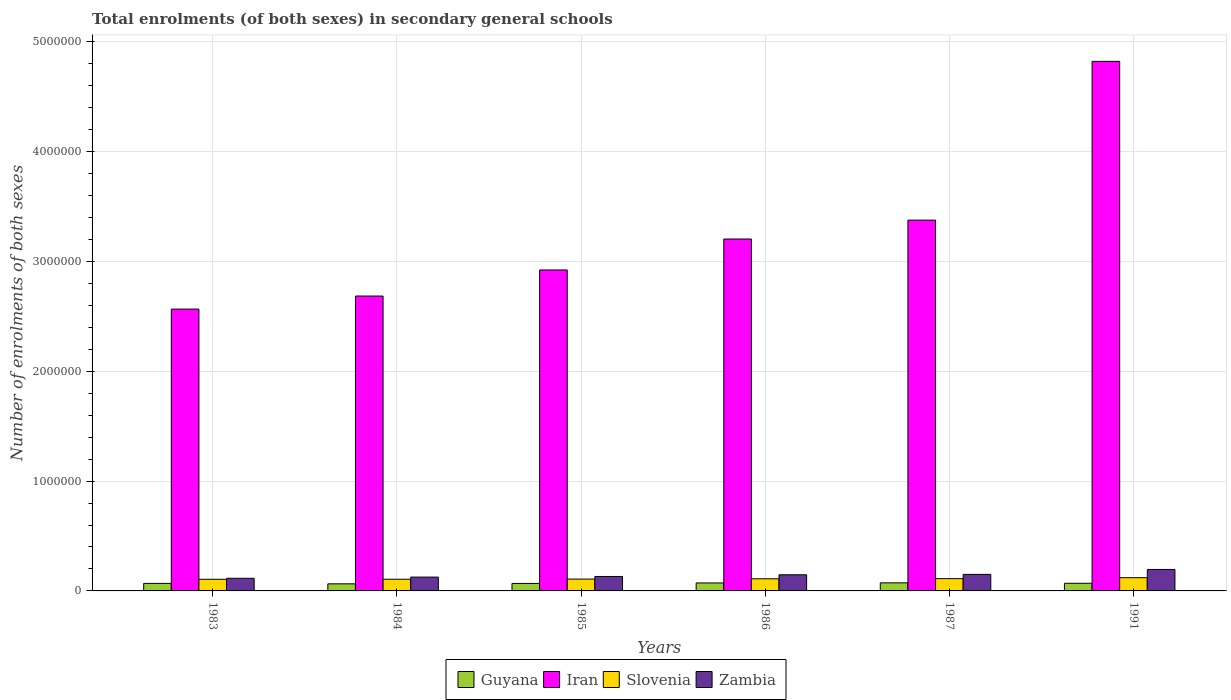Are the number of bars per tick equal to the number of legend labels?
Ensure brevity in your answer.  Yes. Are the number of bars on each tick of the X-axis equal?
Give a very brief answer. Yes. How many bars are there on the 3rd tick from the left?
Ensure brevity in your answer.  4. In how many cases, is the number of bars for a given year not equal to the number of legend labels?
Your response must be concise. 0. What is the number of enrolments in secondary schools in Zambia in 1987?
Offer a terse response. 1.51e+05. Across all years, what is the maximum number of enrolments in secondary schools in Slovenia?
Give a very brief answer. 1.20e+05. Across all years, what is the minimum number of enrolments in secondary schools in Iran?
Keep it short and to the point. 2.57e+06. In which year was the number of enrolments in secondary schools in Zambia minimum?
Offer a very short reply. 1983. What is the total number of enrolments in secondary schools in Guyana in the graph?
Provide a succinct answer. 4.17e+05. What is the difference between the number of enrolments in secondary schools in Slovenia in 1985 and that in 1991?
Your answer should be compact. -1.27e+04. What is the difference between the number of enrolments in secondary schools in Slovenia in 1986 and the number of enrolments in secondary schools in Iran in 1987?
Provide a short and direct response. -3.27e+06. What is the average number of enrolments in secondary schools in Iran per year?
Provide a short and direct response. 3.26e+06. In the year 1983, what is the difference between the number of enrolments in secondary schools in Iran and number of enrolments in secondary schools in Slovenia?
Offer a terse response. 2.46e+06. In how many years, is the number of enrolments in secondary schools in Zambia greater than 3600000?
Provide a short and direct response. 0. What is the ratio of the number of enrolments in secondary schools in Guyana in 1983 to that in 1985?
Your answer should be very brief. 1. Is the number of enrolments in secondary schools in Guyana in 1984 less than that in 1991?
Offer a very short reply. Yes. What is the difference between the highest and the second highest number of enrolments in secondary schools in Zambia?
Give a very brief answer. 4.48e+04. What is the difference between the highest and the lowest number of enrolments in secondary schools in Slovenia?
Your answer should be very brief. 1.45e+04. Is it the case that in every year, the sum of the number of enrolments in secondary schools in Iran and number of enrolments in secondary schools in Slovenia is greater than the sum of number of enrolments in secondary schools in Guyana and number of enrolments in secondary schools in Zambia?
Give a very brief answer. Yes. What does the 1st bar from the left in 1991 represents?
Offer a terse response. Guyana. What does the 2nd bar from the right in 1985 represents?
Offer a very short reply. Slovenia. Is it the case that in every year, the sum of the number of enrolments in secondary schools in Zambia and number of enrolments in secondary schools in Guyana is greater than the number of enrolments in secondary schools in Iran?
Your answer should be very brief. No. How many bars are there?
Make the answer very short. 24. Are all the bars in the graph horizontal?
Offer a terse response. No. How many years are there in the graph?
Ensure brevity in your answer.  6. Are the values on the major ticks of Y-axis written in scientific E-notation?
Your response must be concise. No. How many legend labels are there?
Keep it short and to the point. 4. What is the title of the graph?
Keep it short and to the point. Total enrolments (of both sexes) in secondary general schools. What is the label or title of the X-axis?
Offer a terse response. Years. What is the label or title of the Y-axis?
Make the answer very short. Number of enrolments of both sexes. What is the Number of enrolments of both sexes in Guyana in 1983?
Provide a succinct answer. 6.86e+04. What is the Number of enrolments of both sexes of Iran in 1983?
Your answer should be very brief. 2.57e+06. What is the Number of enrolments of both sexes of Slovenia in 1983?
Offer a very short reply. 1.06e+05. What is the Number of enrolments of both sexes of Zambia in 1983?
Offer a very short reply. 1.15e+05. What is the Number of enrolments of both sexes in Guyana in 1984?
Provide a succinct answer. 6.45e+04. What is the Number of enrolments of both sexes in Iran in 1984?
Offer a terse response. 2.69e+06. What is the Number of enrolments of both sexes in Slovenia in 1984?
Offer a very short reply. 1.06e+05. What is the Number of enrolments of both sexes of Zambia in 1984?
Keep it short and to the point. 1.26e+05. What is the Number of enrolments of both sexes in Guyana in 1985?
Make the answer very short. 6.82e+04. What is the Number of enrolments of both sexes in Iran in 1985?
Give a very brief answer. 2.92e+06. What is the Number of enrolments of both sexes in Slovenia in 1985?
Make the answer very short. 1.08e+05. What is the Number of enrolments of both sexes in Zambia in 1985?
Your answer should be very brief. 1.32e+05. What is the Number of enrolments of both sexes in Guyana in 1986?
Offer a very short reply. 7.27e+04. What is the Number of enrolments of both sexes of Iran in 1986?
Your answer should be very brief. 3.20e+06. What is the Number of enrolments of both sexes of Slovenia in 1986?
Your answer should be compact. 1.10e+05. What is the Number of enrolments of both sexes in Zambia in 1986?
Offer a terse response. 1.47e+05. What is the Number of enrolments of both sexes in Guyana in 1987?
Your answer should be very brief. 7.34e+04. What is the Number of enrolments of both sexes in Iran in 1987?
Keep it short and to the point. 3.38e+06. What is the Number of enrolments of both sexes of Slovenia in 1987?
Offer a very short reply. 1.12e+05. What is the Number of enrolments of both sexes in Zambia in 1987?
Your answer should be very brief. 1.51e+05. What is the Number of enrolments of both sexes in Guyana in 1991?
Keep it short and to the point. 6.97e+04. What is the Number of enrolments of both sexes of Iran in 1991?
Offer a very short reply. 4.82e+06. What is the Number of enrolments of both sexes in Slovenia in 1991?
Your response must be concise. 1.20e+05. What is the Number of enrolments of both sexes in Zambia in 1991?
Keep it short and to the point. 1.95e+05. Across all years, what is the maximum Number of enrolments of both sexes in Guyana?
Provide a short and direct response. 7.34e+04. Across all years, what is the maximum Number of enrolments of both sexes in Iran?
Make the answer very short. 4.82e+06. Across all years, what is the maximum Number of enrolments of both sexes in Slovenia?
Offer a very short reply. 1.20e+05. Across all years, what is the maximum Number of enrolments of both sexes in Zambia?
Your answer should be compact. 1.95e+05. Across all years, what is the minimum Number of enrolments of both sexes of Guyana?
Provide a short and direct response. 6.45e+04. Across all years, what is the minimum Number of enrolments of both sexes of Iran?
Provide a succinct answer. 2.57e+06. Across all years, what is the minimum Number of enrolments of both sexes in Slovenia?
Provide a succinct answer. 1.06e+05. Across all years, what is the minimum Number of enrolments of both sexes of Zambia?
Provide a short and direct response. 1.15e+05. What is the total Number of enrolments of both sexes of Guyana in the graph?
Your answer should be compact. 4.17e+05. What is the total Number of enrolments of both sexes of Iran in the graph?
Ensure brevity in your answer.  1.96e+07. What is the total Number of enrolments of both sexes of Slovenia in the graph?
Give a very brief answer. 6.63e+05. What is the total Number of enrolments of both sexes in Zambia in the graph?
Provide a short and direct response. 8.65e+05. What is the difference between the Number of enrolments of both sexes in Guyana in 1983 and that in 1984?
Offer a terse response. 4042. What is the difference between the Number of enrolments of both sexes of Iran in 1983 and that in 1984?
Give a very brief answer. -1.19e+05. What is the difference between the Number of enrolments of both sexes of Slovenia in 1983 and that in 1984?
Ensure brevity in your answer.  -549. What is the difference between the Number of enrolments of both sexes in Zambia in 1983 and that in 1984?
Keep it short and to the point. -1.07e+04. What is the difference between the Number of enrolments of both sexes of Guyana in 1983 and that in 1985?
Your response must be concise. 338. What is the difference between the Number of enrolments of both sexes of Iran in 1983 and that in 1985?
Your response must be concise. -3.56e+05. What is the difference between the Number of enrolments of both sexes of Slovenia in 1983 and that in 1985?
Make the answer very short. -1803. What is the difference between the Number of enrolments of both sexes in Zambia in 1983 and that in 1985?
Ensure brevity in your answer.  -1.64e+04. What is the difference between the Number of enrolments of both sexes of Guyana in 1983 and that in 1986?
Your response must be concise. -4119. What is the difference between the Number of enrolments of both sexes of Iran in 1983 and that in 1986?
Provide a succinct answer. -6.38e+05. What is the difference between the Number of enrolments of both sexes in Slovenia in 1983 and that in 1986?
Provide a succinct answer. -4548. What is the difference between the Number of enrolments of both sexes of Zambia in 1983 and that in 1986?
Keep it short and to the point. -3.19e+04. What is the difference between the Number of enrolments of both sexes in Guyana in 1983 and that in 1987?
Offer a terse response. -4858. What is the difference between the Number of enrolments of both sexes of Iran in 1983 and that in 1987?
Your answer should be very brief. -8.10e+05. What is the difference between the Number of enrolments of both sexes of Slovenia in 1983 and that in 1987?
Your answer should be compact. -5908. What is the difference between the Number of enrolments of both sexes in Zambia in 1983 and that in 1987?
Give a very brief answer. -3.56e+04. What is the difference between the Number of enrolments of both sexes in Guyana in 1983 and that in 1991?
Keep it short and to the point. -1136. What is the difference between the Number of enrolments of both sexes in Iran in 1983 and that in 1991?
Offer a very short reply. -2.26e+06. What is the difference between the Number of enrolments of both sexes in Slovenia in 1983 and that in 1991?
Ensure brevity in your answer.  -1.45e+04. What is the difference between the Number of enrolments of both sexes in Zambia in 1983 and that in 1991?
Ensure brevity in your answer.  -8.03e+04. What is the difference between the Number of enrolments of both sexes in Guyana in 1984 and that in 1985?
Keep it short and to the point. -3704. What is the difference between the Number of enrolments of both sexes in Iran in 1984 and that in 1985?
Your answer should be compact. -2.38e+05. What is the difference between the Number of enrolments of both sexes of Slovenia in 1984 and that in 1985?
Your answer should be compact. -1254. What is the difference between the Number of enrolments of both sexes in Zambia in 1984 and that in 1985?
Keep it short and to the point. -5691. What is the difference between the Number of enrolments of both sexes in Guyana in 1984 and that in 1986?
Your response must be concise. -8161. What is the difference between the Number of enrolments of both sexes of Iran in 1984 and that in 1986?
Provide a succinct answer. -5.19e+05. What is the difference between the Number of enrolments of both sexes in Slovenia in 1984 and that in 1986?
Ensure brevity in your answer.  -3999. What is the difference between the Number of enrolments of both sexes of Zambia in 1984 and that in 1986?
Make the answer very short. -2.12e+04. What is the difference between the Number of enrolments of both sexes in Guyana in 1984 and that in 1987?
Give a very brief answer. -8900. What is the difference between the Number of enrolments of both sexes of Iran in 1984 and that in 1987?
Make the answer very short. -6.91e+05. What is the difference between the Number of enrolments of both sexes in Slovenia in 1984 and that in 1987?
Ensure brevity in your answer.  -5359. What is the difference between the Number of enrolments of both sexes in Zambia in 1984 and that in 1987?
Keep it short and to the point. -2.48e+04. What is the difference between the Number of enrolments of both sexes in Guyana in 1984 and that in 1991?
Provide a short and direct response. -5178. What is the difference between the Number of enrolments of both sexes of Iran in 1984 and that in 1991?
Give a very brief answer. -2.14e+06. What is the difference between the Number of enrolments of both sexes of Slovenia in 1984 and that in 1991?
Your answer should be compact. -1.40e+04. What is the difference between the Number of enrolments of both sexes of Zambia in 1984 and that in 1991?
Give a very brief answer. -6.96e+04. What is the difference between the Number of enrolments of both sexes in Guyana in 1985 and that in 1986?
Your response must be concise. -4457. What is the difference between the Number of enrolments of both sexes of Iran in 1985 and that in 1986?
Keep it short and to the point. -2.82e+05. What is the difference between the Number of enrolments of both sexes of Slovenia in 1985 and that in 1986?
Ensure brevity in your answer.  -2745. What is the difference between the Number of enrolments of both sexes in Zambia in 1985 and that in 1986?
Offer a very short reply. -1.55e+04. What is the difference between the Number of enrolments of both sexes of Guyana in 1985 and that in 1987?
Offer a very short reply. -5196. What is the difference between the Number of enrolments of both sexes of Iran in 1985 and that in 1987?
Give a very brief answer. -4.54e+05. What is the difference between the Number of enrolments of both sexes in Slovenia in 1985 and that in 1987?
Your answer should be compact. -4105. What is the difference between the Number of enrolments of both sexes in Zambia in 1985 and that in 1987?
Make the answer very short. -1.91e+04. What is the difference between the Number of enrolments of both sexes in Guyana in 1985 and that in 1991?
Offer a very short reply. -1474. What is the difference between the Number of enrolments of both sexes of Iran in 1985 and that in 1991?
Your answer should be compact. -1.90e+06. What is the difference between the Number of enrolments of both sexes in Slovenia in 1985 and that in 1991?
Your answer should be very brief. -1.27e+04. What is the difference between the Number of enrolments of both sexes of Zambia in 1985 and that in 1991?
Offer a terse response. -6.39e+04. What is the difference between the Number of enrolments of both sexes of Guyana in 1986 and that in 1987?
Your answer should be compact. -739. What is the difference between the Number of enrolments of both sexes in Iran in 1986 and that in 1987?
Give a very brief answer. -1.72e+05. What is the difference between the Number of enrolments of both sexes in Slovenia in 1986 and that in 1987?
Make the answer very short. -1360. What is the difference between the Number of enrolments of both sexes of Zambia in 1986 and that in 1987?
Offer a terse response. -3660. What is the difference between the Number of enrolments of both sexes in Guyana in 1986 and that in 1991?
Give a very brief answer. 2983. What is the difference between the Number of enrolments of both sexes in Iran in 1986 and that in 1991?
Make the answer very short. -1.62e+06. What is the difference between the Number of enrolments of both sexes of Slovenia in 1986 and that in 1991?
Your answer should be compact. -9958. What is the difference between the Number of enrolments of both sexes in Zambia in 1986 and that in 1991?
Make the answer very short. -4.84e+04. What is the difference between the Number of enrolments of both sexes of Guyana in 1987 and that in 1991?
Offer a very short reply. 3722. What is the difference between the Number of enrolments of both sexes of Iran in 1987 and that in 1991?
Keep it short and to the point. -1.45e+06. What is the difference between the Number of enrolments of both sexes of Slovenia in 1987 and that in 1991?
Provide a succinct answer. -8598. What is the difference between the Number of enrolments of both sexes in Zambia in 1987 and that in 1991?
Your response must be concise. -4.48e+04. What is the difference between the Number of enrolments of both sexes in Guyana in 1983 and the Number of enrolments of both sexes in Iran in 1984?
Offer a very short reply. -2.62e+06. What is the difference between the Number of enrolments of both sexes in Guyana in 1983 and the Number of enrolments of both sexes in Slovenia in 1984?
Offer a very short reply. -3.79e+04. What is the difference between the Number of enrolments of both sexes in Guyana in 1983 and the Number of enrolments of both sexes in Zambia in 1984?
Your answer should be compact. -5.73e+04. What is the difference between the Number of enrolments of both sexes in Iran in 1983 and the Number of enrolments of both sexes in Slovenia in 1984?
Your answer should be compact. 2.46e+06. What is the difference between the Number of enrolments of both sexes of Iran in 1983 and the Number of enrolments of both sexes of Zambia in 1984?
Offer a very short reply. 2.44e+06. What is the difference between the Number of enrolments of both sexes of Slovenia in 1983 and the Number of enrolments of both sexes of Zambia in 1984?
Provide a succinct answer. -1.99e+04. What is the difference between the Number of enrolments of both sexes in Guyana in 1983 and the Number of enrolments of both sexes in Iran in 1985?
Your answer should be compact. -2.85e+06. What is the difference between the Number of enrolments of both sexes of Guyana in 1983 and the Number of enrolments of both sexes of Slovenia in 1985?
Provide a short and direct response. -3.91e+04. What is the difference between the Number of enrolments of both sexes in Guyana in 1983 and the Number of enrolments of both sexes in Zambia in 1985?
Keep it short and to the point. -6.29e+04. What is the difference between the Number of enrolments of both sexes in Iran in 1983 and the Number of enrolments of both sexes in Slovenia in 1985?
Offer a terse response. 2.46e+06. What is the difference between the Number of enrolments of both sexes of Iran in 1983 and the Number of enrolments of both sexes of Zambia in 1985?
Offer a very short reply. 2.43e+06. What is the difference between the Number of enrolments of both sexes in Slovenia in 1983 and the Number of enrolments of both sexes in Zambia in 1985?
Your answer should be compact. -2.56e+04. What is the difference between the Number of enrolments of both sexes of Guyana in 1983 and the Number of enrolments of both sexes of Iran in 1986?
Give a very brief answer. -3.14e+06. What is the difference between the Number of enrolments of both sexes of Guyana in 1983 and the Number of enrolments of both sexes of Slovenia in 1986?
Your answer should be very brief. -4.19e+04. What is the difference between the Number of enrolments of both sexes of Guyana in 1983 and the Number of enrolments of both sexes of Zambia in 1986?
Your answer should be very brief. -7.84e+04. What is the difference between the Number of enrolments of both sexes of Iran in 1983 and the Number of enrolments of both sexes of Slovenia in 1986?
Your answer should be compact. 2.46e+06. What is the difference between the Number of enrolments of both sexes in Iran in 1983 and the Number of enrolments of both sexes in Zambia in 1986?
Give a very brief answer. 2.42e+06. What is the difference between the Number of enrolments of both sexes of Slovenia in 1983 and the Number of enrolments of both sexes of Zambia in 1986?
Offer a very short reply. -4.11e+04. What is the difference between the Number of enrolments of both sexes of Guyana in 1983 and the Number of enrolments of both sexes of Iran in 1987?
Provide a succinct answer. -3.31e+06. What is the difference between the Number of enrolments of both sexes in Guyana in 1983 and the Number of enrolments of both sexes in Slovenia in 1987?
Make the answer very short. -4.32e+04. What is the difference between the Number of enrolments of both sexes of Guyana in 1983 and the Number of enrolments of both sexes of Zambia in 1987?
Provide a short and direct response. -8.21e+04. What is the difference between the Number of enrolments of both sexes of Iran in 1983 and the Number of enrolments of both sexes of Slovenia in 1987?
Offer a terse response. 2.45e+06. What is the difference between the Number of enrolments of both sexes in Iran in 1983 and the Number of enrolments of both sexes in Zambia in 1987?
Offer a terse response. 2.42e+06. What is the difference between the Number of enrolments of both sexes in Slovenia in 1983 and the Number of enrolments of both sexes in Zambia in 1987?
Offer a terse response. -4.47e+04. What is the difference between the Number of enrolments of both sexes of Guyana in 1983 and the Number of enrolments of both sexes of Iran in 1991?
Offer a terse response. -4.75e+06. What is the difference between the Number of enrolments of both sexes of Guyana in 1983 and the Number of enrolments of both sexes of Slovenia in 1991?
Provide a succinct answer. -5.18e+04. What is the difference between the Number of enrolments of both sexes of Guyana in 1983 and the Number of enrolments of both sexes of Zambia in 1991?
Make the answer very short. -1.27e+05. What is the difference between the Number of enrolments of both sexes of Iran in 1983 and the Number of enrolments of both sexes of Slovenia in 1991?
Provide a succinct answer. 2.45e+06. What is the difference between the Number of enrolments of both sexes in Iran in 1983 and the Number of enrolments of both sexes in Zambia in 1991?
Your answer should be very brief. 2.37e+06. What is the difference between the Number of enrolments of both sexes in Slovenia in 1983 and the Number of enrolments of both sexes in Zambia in 1991?
Keep it short and to the point. -8.95e+04. What is the difference between the Number of enrolments of both sexes in Guyana in 1984 and the Number of enrolments of both sexes in Iran in 1985?
Your response must be concise. -2.86e+06. What is the difference between the Number of enrolments of both sexes of Guyana in 1984 and the Number of enrolments of both sexes of Slovenia in 1985?
Provide a succinct answer. -4.32e+04. What is the difference between the Number of enrolments of both sexes in Guyana in 1984 and the Number of enrolments of both sexes in Zambia in 1985?
Offer a very short reply. -6.70e+04. What is the difference between the Number of enrolments of both sexes of Iran in 1984 and the Number of enrolments of both sexes of Slovenia in 1985?
Provide a succinct answer. 2.58e+06. What is the difference between the Number of enrolments of both sexes in Iran in 1984 and the Number of enrolments of both sexes in Zambia in 1985?
Offer a terse response. 2.55e+06. What is the difference between the Number of enrolments of both sexes of Slovenia in 1984 and the Number of enrolments of both sexes of Zambia in 1985?
Make the answer very short. -2.51e+04. What is the difference between the Number of enrolments of both sexes in Guyana in 1984 and the Number of enrolments of both sexes in Iran in 1986?
Keep it short and to the point. -3.14e+06. What is the difference between the Number of enrolments of both sexes of Guyana in 1984 and the Number of enrolments of both sexes of Slovenia in 1986?
Your answer should be very brief. -4.59e+04. What is the difference between the Number of enrolments of both sexes in Guyana in 1984 and the Number of enrolments of both sexes in Zambia in 1986?
Make the answer very short. -8.25e+04. What is the difference between the Number of enrolments of both sexes in Iran in 1984 and the Number of enrolments of both sexes in Slovenia in 1986?
Provide a short and direct response. 2.57e+06. What is the difference between the Number of enrolments of both sexes of Iran in 1984 and the Number of enrolments of both sexes of Zambia in 1986?
Your response must be concise. 2.54e+06. What is the difference between the Number of enrolments of both sexes in Slovenia in 1984 and the Number of enrolments of both sexes in Zambia in 1986?
Keep it short and to the point. -4.05e+04. What is the difference between the Number of enrolments of both sexes of Guyana in 1984 and the Number of enrolments of both sexes of Iran in 1987?
Make the answer very short. -3.31e+06. What is the difference between the Number of enrolments of both sexes of Guyana in 1984 and the Number of enrolments of both sexes of Slovenia in 1987?
Offer a very short reply. -4.73e+04. What is the difference between the Number of enrolments of both sexes in Guyana in 1984 and the Number of enrolments of both sexes in Zambia in 1987?
Offer a terse response. -8.61e+04. What is the difference between the Number of enrolments of both sexes in Iran in 1984 and the Number of enrolments of both sexes in Slovenia in 1987?
Provide a short and direct response. 2.57e+06. What is the difference between the Number of enrolments of both sexes of Iran in 1984 and the Number of enrolments of both sexes of Zambia in 1987?
Keep it short and to the point. 2.53e+06. What is the difference between the Number of enrolments of both sexes of Slovenia in 1984 and the Number of enrolments of both sexes of Zambia in 1987?
Your response must be concise. -4.42e+04. What is the difference between the Number of enrolments of both sexes of Guyana in 1984 and the Number of enrolments of both sexes of Iran in 1991?
Offer a very short reply. -4.76e+06. What is the difference between the Number of enrolments of both sexes in Guyana in 1984 and the Number of enrolments of both sexes in Slovenia in 1991?
Keep it short and to the point. -5.59e+04. What is the difference between the Number of enrolments of both sexes of Guyana in 1984 and the Number of enrolments of both sexes of Zambia in 1991?
Your answer should be very brief. -1.31e+05. What is the difference between the Number of enrolments of both sexes of Iran in 1984 and the Number of enrolments of both sexes of Slovenia in 1991?
Make the answer very short. 2.56e+06. What is the difference between the Number of enrolments of both sexes in Iran in 1984 and the Number of enrolments of both sexes in Zambia in 1991?
Your answer should be compact. 2.49e+06. What is the difference between the Number of enrolments of both sexes in Slovenia in 1984 and the Number of enrolments of both sexes in Zambia in 1991?
Your answer should be very brief. -8.90e+04. What is the difference between the Number of enrolments of both sexes of Guyana in 1985 and the Number of enrolments of both sexes of Iran in 1986?
Keep it short and to the point. -3.14e+06. What is the difference between the Number of enrolments of both sexes in Guyana in 1985 and the Number of enrolments of both sexes in Slovenia in 1986?
Offer a terse response. -4.22e+04. What is the difference between the Number of enrolments of both sexes in Guyana in 1985 and the Number of enrolments of both sexes in Zambia in 1986?
Provide a short and direct response. -7.88e+04. What is the difference between the Number of enrolments of both sexes in Iran in 1985 and the Number of enrolments of both sexes in Slovenia in 1986?
Your response must be concise. 2.81e+06. What is the difference between the Number of enrolments of both sexes in Iran in 1985 and the Number of enrolments of both sexes in Zambia in 1986?
Provide a succinct answer. 2.78e+06. What is the difference between the Number of enrolments of both sexes in Slovenia in 1985 and the Number of enrolments of both sexes in Zambia in 1986?
Offer a terse response. -3.93e+04. What is the difference between the Number of enrolments of both sexes of Guyana in 1985 and the Number of enrolments of both sexes of Iran in 1987?
Your answer should be very brief. -3.31e+06. What is the difference between the Number of enrolments of both sexes in Guyana in 1985 and the Number of enrolments of both sexes in Slovenia in 1987?
Give a very brief answer. -4.36e+04. What is the difference between the Number of enrolments of both sexes of Guyana in 1985 and the Number of enrolments of both sexes of Zambia in 1987?
Offer a very short reply. -8.24e+04. What is the difference between the Number of enrolments of both sexes of Iran in 1985 and the Number of enrolments of both sexes of Slovenia in 1987?
Provide a succinct answer. 2.81e+06. What is the difference between the Number of enrolments of both sexes in Iran in 1985 and the Number of enrolments of both sexes in Zambia in 1987?
Provide a succinct answer. 2.77e+06. What is the difference between the Number of enrolments of both sexes of Slovenia in 1985 and the Number of enrolments of both sexes of Zambia in 1987?
Provide a short and direct response. -4.29e+04. What is the difference between the Number of enrolments of both sexes in Guyana in 1985 and the Number of enrolments of both sexes in Iran in 1991?
Provide a succinct answer. -4.75e+06. What is the difference between the Number of enrolments of both sexes of Guyana in 1985 and the Number of enrolments of both sexes of Slovenia in 1991?
Offer a terse response. -5.22e+04. What is the difference between the Number of enrolments of both sexes in Guyana in 1985 and the Number of enrolments of both sexes in Zambia in 1991?
Keep it short and to the point. -1.27e+05. What is the difference between the Number of enrolments of both sexes of Iran in 1985 and the Number of enrolments of both sexes of Slovenia in 1991?
Ensure brevity in your answer.  2.80e+06. What is the difference between the Number of enrolments of both sexes of Iran in 1985 and the Number of enrolments of both sexes of Zambia in 1991?
Your answer should be compact. 2.73e+06. What is the difference between the Number of enrolments of both sexes of Slovenia in 1985 and the Number of enrolments of both sexes of Zambia in 1991?
Offer a very short reply. -8.77e+04. What is the difference between the Number of enrolments of both sexes of Guyana in 1986 and the Number of enrolments of both sexes of Iran in 1987?
Keep it short and to the point. -3.30e+06. What is the difference between the Number of enrolments of both sexes of Guyana in 1986 and the Number of enrolments of both sexes of Slovenia in 1987?
Offer a very short reply. -3.91e+04. What is the difference between the Number of enrolments of both sexes in Guyana in 1986 and the Number of enrolments of both sexes in Zambia in 1987?
Your answer should be compact. -7.80e+04. What is the difference between the Number of enrolments of both sexes of Iran in 1986 and the Number of enrolments of both sexes of Slovenia in 1987?
Provide a succinct answer. 3.09e+06. What is the difference between the Number of enrolments of both sexes of Iran in 1986 and the Number of enrolments of both sexes of Zambia in 1987?
Give a very brief answer. 3.05e+06. What is the difference between the Number of enrolments of both sexes in Slovenia in 1986 and the Number of enrolments of both sexes in Zambia in 1987?
Offer a very short reply. -4.02e+04. What is the difference between the Number of enrolments of both sexes of Guyana in 1986 and the Number of enrolments of both sexes of Iran in 1991?
Provide a short and direct response. -4.75e+06. What is the difference between the Number of enrolments of both sexes in Guyana in 1986 and the Number of enrolments of both sexes in Slovenia in 1991?
Provide a short and direct response. -4.77e+04. What is the difference between the Number of enrolments of both sexes in Guyana in 1986 and the Number of enrolments of both sexes in Zambia in 1991?
Give a very brief answer. -1.23e+05. What is the difference between the Number of enrolments of both sexes in Iran in 1986 and the Number of enrolments of both sexes in Slovenia in 1991?
Give a very brief answer. 3.08e+06. What is the difference between the Number of enrolments of both sexes in Iran in 1986 and the Number of enrolments of both sexes in Zambia in 1991?
Keep it short and to the point. 3.01e+06. What is the difference between the Number of enrolments of both sexes of Slovenia in 1986 and the Number of enrolments of both sexes of Zambia in 1991?
Provide a succinct answer. -8.50e+04. What is the difference between the Number of enrolments of both sexes in Guyana in 1987 and the Number of enrolments of both sexes in Iran in 1991?
Ensure brevity in your answer.  -4.75e+06. What is the difference between the Number of enrolments of both sexes of Guyana in 1987 and the Number of enrolments of both sexes of Slovenia in 1991?
Your answer should be compact. -4.70e+04. What is the difference between the Number of enrolments of both sexes in Guyana in 1987 and the Number of enrolments of both sexes in Zambia in 1991?
Keep it short and to the point. -1.22e+05. What is the difference between the Number of enrolments of both sexes of Iran in 1987 and the Number of enrolments of both sexes of Slovenia in 1991?
Offer a terse response. 3.26e+06. What is the difference between the Number of enrolments of both sexes in Iran in 1987 and the Number of enrolments of both sexes in Zambia in 1991?
Keep it short and to the point. 3.18e+06. What is the difference between the Number of enrolments of both sexes of Slovenia in 1987 and the Number of enrolments of both sexes of Zambia in 1991?
Offer a very short reply. -8.36e+04. What is the average Number of enrolments of both sexes in Guyana per year?
Make the answer very short. 6.95e+04. What is the average Number of enrolments of both sexes of Iran per year?
Make the answer very short. 3.26e+06. What is the average Number of enrolments of both sexes in Slovenia per year?
Make the answer very short. 1.10e+05. What is the average Number of enrolments of both sexes of Zambia per year?
Your response must be concise. 1.44e+05. In the year 1983, what is the difference between the Number of enrolments of both sexes of Guyana and Number of enrolments of both sexes of Iran?
Provide a short and direct response. -2.50e+06. In the year 1983, what is the difference between the Number of enrolments of both sexes in Guyana and Number of enrolments of both sexes in Slovenia?
Keep it short and to the point. -3.73e+04. In the year 1983, what is the difference between the Number of enrolments of both sexes of Guyana and Number of enrolments of both sexes of Zambia?
Provide a succinct answer. -4.65e+04. In the year 1983, what is the difference between the Number of enrolments of both sexes of Iran and Number of enrolments of both sexes of Slovenia?
Offer a very short reply. 2.46e+06. In the year 1983, what is the difference between the Number of enrolments of both sexes of Iran and Number of enrolments of both sexes of Zambia?
Your answer should be very brief. 2.45e+06. In the year 1983, what is the difference between the Number of enrolments of both sexes in Slovenia and Number of enrolments of both sexes in Zambia?
Provide a succinct answer. -9192. In the year 1984, what is the difference between the Number of enrolments of both sexes in Guyana and Number of enrolments of both sexes in Iran?
Your answer should be very brief. -2.62e+06. In the year 1984, what is the difference between the Number of enrolments of both sexes of Guyana and Number of enrolments of both sexes of Slovenia?
Provide a short and direct response. -4.19e+04. In the year 1984, what is the difference between the Number of enrolments of both sexes of Guyana and Number of enrolments of both sexes of Zambia?
Keep it short and to the point. -6.13e+04. In the year 1984, what is the difference between the Number of enrolments of both sexes in Iran and Number of enrolments of both sexes in Slovenia?
Give a very brief answer. 2.58e+06. In the year 1984, what is the difference between the Number of enrolments of both sexes of Iran and Number of enrolments of both sexes of Zambia?
Provide a succinct answer. 2.56e+06. In the year 1984, what is the difference between the Number of enrolments of both sexes in Slovenia and Number of enrolments of both sexes in Zambia?
Offer a terse response. -1.94e+04. In the year 1985, what is the difference between the Number of enrolments of both sexes of Guyana and Number of enrolments of both sexes of Iran?
Offer a terse response. -2.85e+06. In the year 1985, what is the difference between the Number of enrolments of both sexes in Guyana and Number of enrolments of both sexes in Slovenia?
Provide a succinct answer. -3.95e+04. In the year 1985, what is the difference between the Number of enrolments of both sexes in Guyana and Number of enrolments of both sexes in Zambia?
Ensure brevity in your answer.  -6.33e+04. In the year 1985, what is the difference between the Number of enrolments of both sexes in Iran and Number of enrolments of both sexes in Slovenia?
Your answer should be very brief. 2.81e+06. In the year 1985, what is the difference between the Number of enrolments of both sexes of Iran and Number of enrolments of both sexes of Zambia?
Ensure brevity in your answer.  2.79e+06. In the year 1985, what is the difference between the Number of enrolments of both sexes in Slovenia and Number of enrolments of both sexes in Zambia?
Give a very brief answer. -2.38e+04. In the year 1986, what is the difference between the Number of enrolments of both sexes in Guyana and Number of enrolments of both sexes in Iran?
Your answer should be compact. -3.13e+06. In the year 1986, what is the difference between the Number of enrolments of both sexes in Guyana and Number of enrolments of both sexes in Slovenia?
Your answer should be very brief. -3.78e+04. In the year 1986, what is the difference between the Number of enrolments of both sexes in Guyana and Number of enrolments of both sexes in Zambia?
Offer a terse response. -7.43e+04. In the year 1986, what is the difference between the Number of enrolments of both sexes of Iran and Number of enrolments of both sexes of Slovenia?
Offer a terse response. 3.09e+06. In the year 1986, what is the difference between the Number of enrolments of both sexes of Iran and Number of enrolments of both sexes of Zambia?
Offer a terse response. 3.06e+06. In the year 1986, what is the difference between the Number of enrolments of both sexes in Slovenia and Number of enrolments of both sexes in Zambia?
Your answer should be compact. -3.65e+04. In the year 1987, what is the difference between the Number of enrolments of both sexes in Guyana and Number of enrolments of both sexes in Iran?
Provide a succinct answer. -3.30e+06. In the year 1987, what is the difference between the Number of enrolments of both sexes in Guyana and Number of enrolments of both sexes in Slovenia?
Your answer should be compact. -3.84e+04. In the year 1987, what is the difference between the Number of enrolments of both sexes of Guyana and Number of enrolments of both sexes of Zambia?
Your answer should be compact. -7.72e+04. In the year 1987, what is the difference between the Number of enrolments of both sexes of Iran and Number of enrolments of both sexes of Slovenia?
Ensure brevity in your answer.  3.26e+06. In the year 1987, what is the difference between the Number of enrolments of both sexes of Iran and Number of enrolments of both sexes of Zambia?
Give a very brief answer. 3.23e+06. In the year 1987, what is the difference between the Number of enrolments of both sexes of Slovenia and Number of enrolments of both sexes of Zambia?
Provide a short and direct response. -3.88e+04. In the year 1991, what is the difference between the Number of enrolments of both sexes of Guyana and Number of enrolments of both sexes of Iran?
Provide a short and direct response. -4.75e+06. In the year 1991, what is the difference between the Number of enrolments of both sexes in Guyana and Number of enrolments of both sexes in Slovenia?
Provide a short and direct response. -5.07e+04. In the year 1991, what is the difference between the Number of enrolments of both sexes of Guyana and Number of enrolments of both sexes of Zambia?
Keep it short and to the point. -1.26e+05. In the year 1991, what is the difference between the Number of enrolments of both sexes of Iran and Number of enrolments of both sexes of Slovenia?
Your answer should be very brief. 4.70e+06. In the year 1991, what is the difference between the Number of enrolments of both sexes of Iran and Number of enrolments of both sexes of Zambia?
Offer a terse response. 4.63e+06. In the year 1991, what is the difference between the Number of enrolments of both sexes in Slovenia and Number of enrolments of both sexes in Zambia?
Give a very brief answer. -7.50e+04. What is the ratio of the Number of enrolments of both sexes of Guyana in 1983 to that in 1984?
Your response must be concise. 1.06. What is the ratio of the Number of enrolments of both sexes in Iran in 1983 to that in 1984?
Provide a short and direct response. 0.96. What is the ratio of the Number of enrolments of both sexes in Zambia in 1983 to that in 1984?
Provide a succinct answer. 0.91. What is the ratio of the Number of enrolments of both sexes of Iran in 1983 to that in 1985?
Your answer should be very brief. 0.88. What is the ratio of the Number of enrolments of both sexes of Slovenia in 1983 to that in 1985?
Offer a terse response. 0.98. What is the ratio of the Number of enrolments of both sexes of Zambia in 1983 to that in 1985?
Offer a very short reply. 0.88. What is the ratio of the Number of enrolments of both sexes of Guyana in 1983 to that in 1986?
Provide a short and direct response. 0.94. What is the ratio of the Number of enrolments of both sexes in Iran in 1983 to that in 1986?
Make the answer very short. 0.8. What is the ratio of the Number of enrolments of both sexes of Slovenia in 1983 to that in 1986?
Provide a succinct answer. 0.96. What is the ratio of the Number of enrolments of both sexes of Zambia in 1983 to that in 1986?
Ensure brevity in your answer.  0.78. What is the ratio of the Number of enrolments of both sexes in Guyana in 1983 to that in 1987?
Make the answer very short. 0.93. What is the ratio of the Number of enrolments of both sexes of Iran in 1983 to that in 1987?
Offer a very short reply. 0.76. What is the ratio of the Number of enrolments of both sexes in Slovenia in 1983 to that in 1987?
Make the answer very short. 0.95. What is the ratio of the Number of enrolments of both sexes of Zambia in 1983 to that in 1987?
Your answer should be very brief. 0.76. What is the ratio of the Number of enrolments of both sexes in Guyana in 1983 to that in 1991?
Provide a short and direct response. 0.98. What is the ratio of the Number of enrolments of both sexes in Iran in 1983 to that in 1991?
Offer a terse response. 0.53. What is the ratio of the Number of enrolments of both sexes in Slovenia in 1983 to that in 1991?
Ensure brevity in your answer.  0.88. What is the ratio of the Number of enrolments of both sexes in Zambia in 1983 to that in 1991?
Make the answer very short. 0.59. What is the ratio of the Number of enrolments of both sexes of Guyana in 1984 to that in 1985?
Offer a very short reply. 0.95. What is the ratio of the Number of enrolments of both sexes of Iran in 1984 to that in 1985?
Keep it short and to the point. 0.92. What is the ratio of the Number of enrolments of both sexes in Slovenia in 1984 to that in 1985?
Give a very brief answer. 0.99. What is the ratio of the Number of enrolments of both sexes of Zambia in 1984 to that in 1985?
Offer a terse response. 0.96. What is the ratio of the Number of enrolments of both sexes in Guyana in 1984 to that in 1986?
Provide a succinct answer. 0.89. What is the ratio of the Number of enrolments of both sexes in Iran in 1984 to that in 1986?
Keep it short and to the point. 0.84. What is the ratio of the Number of enrolments of both sexes in Slovenia in 1984 to that in 1986?
Ensure brevity in your answer.  0.96. What is the ratio of the Number of enrolments of both sexes of Zambia in 1984 to that in 1986?
Provide a succinct answer. 0.86. What is the ratio of the Number of enrolments of both sexes of Guyana in 1984 to that in 1987?
Your answer should be compact. 0.88. What is the ratio of the Number of enrolments of both sexes of Iran in 1984 to that in 1987?
Keep it short and to the point. 0.8. What is the ratio of the Number of enrolments of both sexes of Slovenia in 1984 to that in 1987?
Provide a short and direct response. 0.95. What is the ratio of the Number of enrolments of both sexes in Zambia in 1984 to that in 1987?
Ensure brevity in your answer.  0.84. What is the ratio of the Number of enrolments of both sexes in Guyana in 1984 to that in 1991?
Offer a terse response. 0.93. What is the ratio of the Number of enrolments of both sexes of Iran in 1984 to that in 1991?
Your answer should be compact. 0.56. What is the ratio of the Number of enrolments of both sexes of Slovenia in 1984 to that in 1991?
Provide a succinct answer. 0.88. What is the ratio of the Number of enrolments of both sexes in Zambia in 1984 to that in 1991?
Your answer should be very brief. 0.64. What is the ratio of the Number of enrolments of both sexes in Guyana in 1985 to that in 1986?
Ensure brevity in your answer.  0.94. What is the ratio of the Number of enrolments of both sexes in Iran in 1985 to that in 1986?
Keep it short and to the point. 0.91. What is the ratio of the Number of enrolments of both sexes of Slovenia in 1985 to that in 1986?
Your answer should be compact. 0.98. What is the ratio of the Number of enrolments of both sexes in Zambia in 1985 to that in 1986?
Keep it short and to the point. 0.89. What is the ratio of the Number of enrolments of both sexes of Guyana in 1985 to that in 1987?
Your answer should be compact. 0.93. What is the ratio of the Number of enrolments of both sexes of Iran in 1985 to that in 1987?
Ensure brevity in your answer.  0.87. What is the ratio of the Number of enrolments of both sexes in Slovenia in 1985 to that in 1987?
Ensure brevity in your answer.  0.96. What is the ratio of the Number of enrolments of both sexes in Zambia in 1985 to that in 1987?
Offer a very short reply. 0.87. What is the ratio of the Number of enrolments of both sexes of Guyana in 1985 to that in 1991?
Your answer should be very brief. 0.98. What is the ratio of the Number of enrolments of both sexes in Iran in 1985 to that in 1991?
Ensure brevity in your answer.  0.61. What is the ratio of the Number of enrolments of both sexes in Slovenia in 1985 to that in 1991?
Your answer should be compact. 0.89. What is the ratio of the Number of enrolments of both sexes of Zambia in 1985 to that in 1991?
Offer a very short reply. 0.67. What is the ratio of the Number of enrolments of both sexes of Guyana in 1986 to that in 1987?
Offer a terse response. 0.99. What is the ratio of the Number of enrolments of both sexes in Iran in 1986 to that in 1987?
Your response must be concise. 0.95. What is the ratio of the Number of enrolments of both sexes of Slovenia in 1986 to that in 1987?
Ensure brevity in your answer.  0.99. What is the ratio of the Number of enrolments of both sexes of Zambia in 1986 to that in 1987?
Your answer should be very brief. 0.98. What is the ratio of the Number of enrolments of both sexes of Guyana in 1986 to that in 1991?
Ensure brevity in your answer.  1.04. What is the ratio of the Number of enrolments of both sexes in Iran in 1986 to that in 1991?
Give a very brief answer. 0.66. What is the ratio of the Number of enrolments of both sexes of Slovenia in 1986 to that in 1991?
Offer a terse response. 0.92. What is the ratio of the Number of enrolments of both sexes of Zambia in 1986 to that in 1991?
Ensure brevity in your answer.  0.75. What is the ratio of the Number of enrolments of both sexes in Guyana in 1987 to that in 1991?
Provide a succinct answer. 1.05. What is the ratio of the Number of enrolments of both sexes of Iran in 1987 to that in 1991?
Give a very brief answer. 0.7. What is the ratio of the Number of enrolments of both sexes of Slovenia in 1987 to that in 1991?
Ensure brevity in your answer.  0.93. What is the ratio of the Number of enrolments of both sexes of Zambia in 1987 to that in 1991?
Offer a terse response. 0.77. What is the difference between the highest and the second highest Number of enrolments of both sexes in Guyana?
Your answer should be compact. 739. What is the difference between the highest and the second highest Number of enrolments of both sexes of Iran?
Your answer should be very brief. 1.45e+06. What is the difference between the highest and the second highest Number of enrolments of both sexes of Slovenia?
Offer a very short reply. 8598. What is the difference between the highest and the second highest Number of enrolments of both sexes in Zambia?
Offer a very short reply. 4.48e+04. What is the difference between the highest and the lowest Number of enrolments of both sexes in Guyana?
Your answer should be very brief. 8900. What is the difference between the highest and the lowest Number of enrolments of both sexes of Iran?
Provide a short and direct response. 2.26e+06. What is the difference between the highest and the lowest Number of enrolments of both sexes of Slovenia?
Ensure brevity in your answer.  1.45e+04. What is the difference between the highest and the lowest Number of enrolments of both sexes of Zambia?
Offer a very short reply. 8.03e+04. 